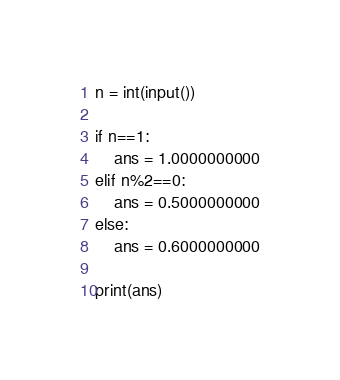<code> <loc_0><loc_0><loc_500><loc_500><_Python_>n = int(input())

if n==1:
    ans = 1.0000000000
elif n%2==0:
    ans = 0.5000000000
else:
    ans = 0.6000000000

print(ans)</code> 